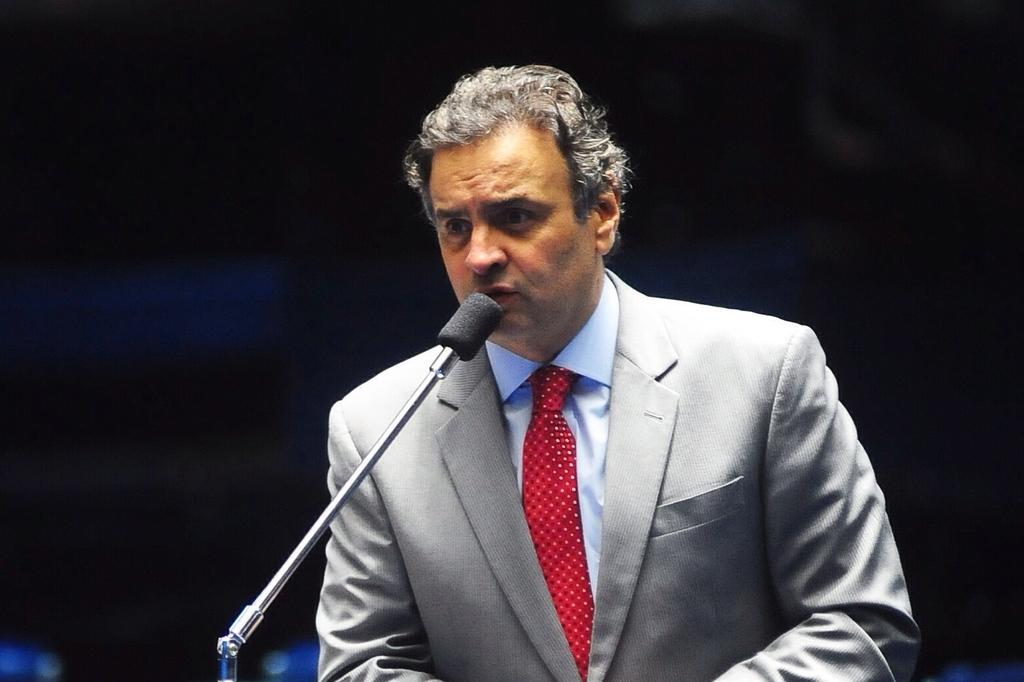Who or what is the main subject of the image? There is a person in the image. What is the person doing in the image? The person is in front of a mic. Can you describe the background of the image? The background of the image is dark. How many oranges are squeezed into the juice in the image? There is no juice or oranges present in the image; it features a person in front of a mic with a dark background. 